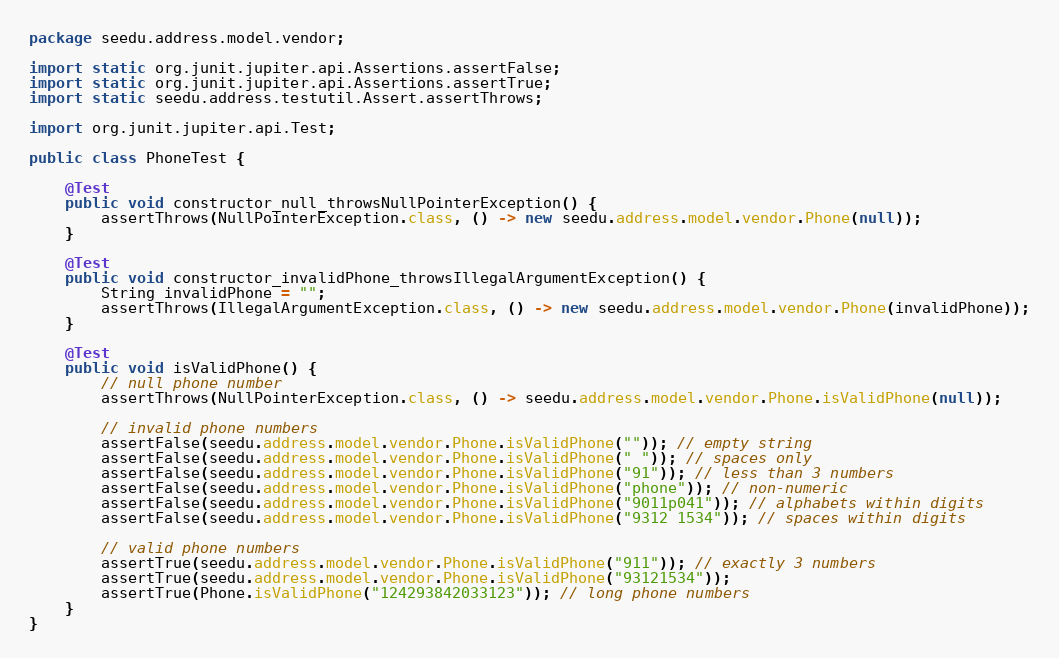Convert code to text. <code><loc_0><loc_0><loc_500><loc_500><_Java_>package seedu.address.model.vendor;

import static org.junit.jupiter.api.Assertions.assertFalse;
import static org.junit.jupiter.api.Assertions.assertTrue;
import static seedu.address.testutil.Assert.assertThrows;

import org.junit.jupiter.api.Test;

public class PhoneTest {

    @Test
    public void constructor_null_throwsNullPointerException() {
        assertThrows(NullPointerException.class, () -> new seedu.address.model.vendor.Phone(null));
    }

    @Test
    public void constructor_invalidPhone_throwsIllegalArgumentException() {
        String invalidPhone = "";
        assertThrows(IllegalArgumentException.class, () -> new seedu.address.model.vendor.Phone(invalidPhone));
    }

    @Test
    public void isValidPhone() {
        // null phone number
        assertThrows(NullPointerException.class, () -> seedu.address.model.vendor.Phone.isValidPhone(null));

        // invalid phone numbers
        assertFalse(seedu.address.model.vendor.Phone.isValidPhone("")); // empty string
        assertFalse(seedu.address.model.vendor.Phone.isValidPhone(" ")); // spaces only
        assertFalse(seedu.address.model.vendor.Phone.isValidPhone("91")); // less than 3 numbers
        assertFalse(seedu.address.model.vendor.Phone.isValidPhone("phone")); // non-numeric
        assertFalse(seedu.address.model.vendor.Phone.isValidPhone("9011p041")); // alphabets within digits
        assertFalse(seedu.address.model.vendor.Phone.isValidPhone("9312 1534")); // spaces within digits

        // valid phone numbers
        assertTrue(seedu.address.model.vendor.Phone.isValidPhone("911")); // exactly 3 numbers
        assertTrue(seedu.address.model.vendor.Phone.isValidPhone("93121534"));
        assertTrue(Phone.isValidPhone("124293842033123")); // long phone numbers
    }
}
</code> 